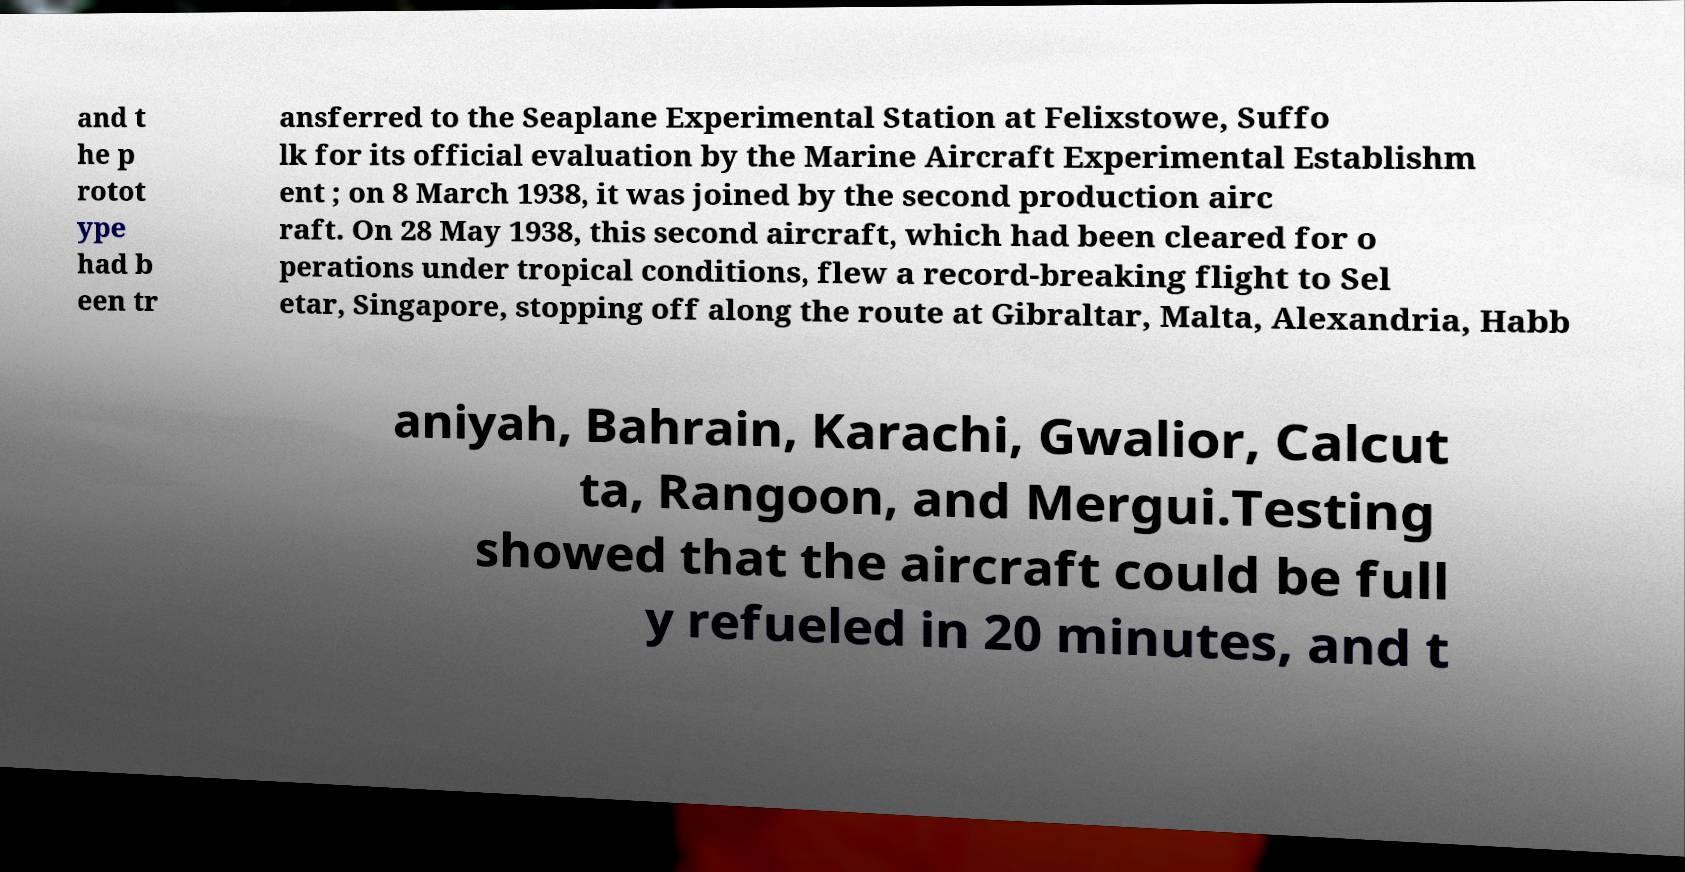Please read and relay the text visible in this image. What does it say? and t he p rotot ype had b een tr ansferred to the Seaplane Experimental Station at Felixstowe, Suffo lk for its official evaluation by the Marine Aircraft Experimental Establishm ent ; on 8 March 1938, it was joined by the second production airc raft. On 28 May 1938, this second aircraft, which had been cleared for o perations under tropical conditions, flew a record-breaking flight to Sel etar, Singapore, stopping off along the route at Gibraltar, Malta, Alexandria, Habb aniyah, Bahrain, Karachi, Gwalior, Calcut ta, Rangoon, and Mergui.Testing showed that the aircraft could be full y refueled in 20 minutes, and t 